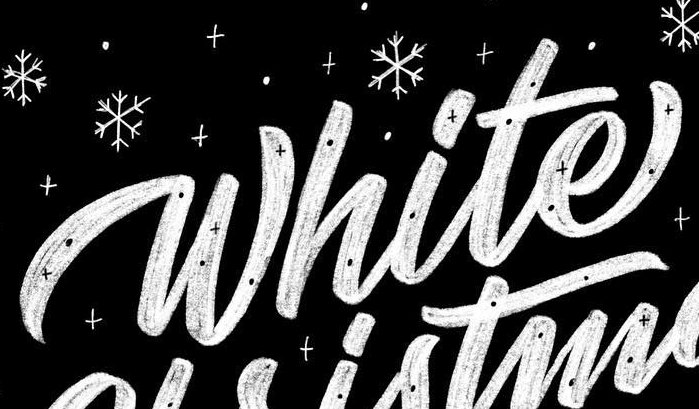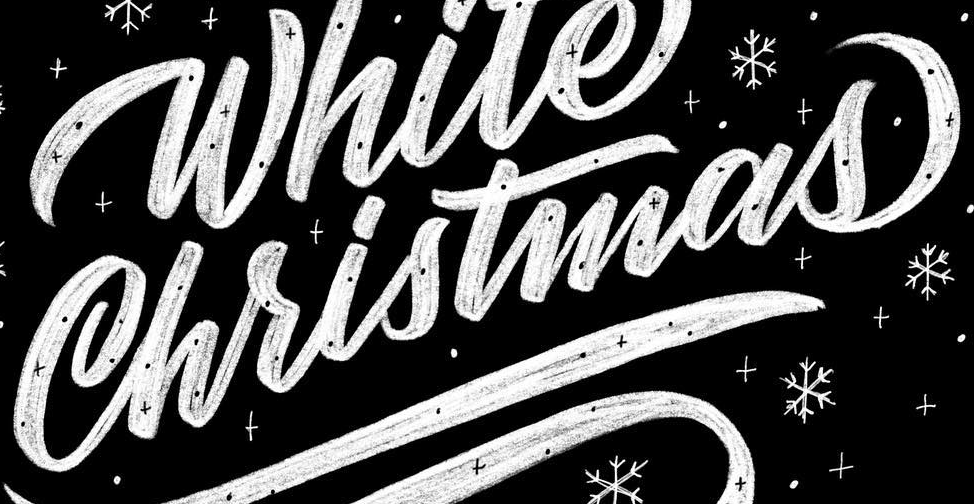What text is displayed in these images sequentially, separated by a semicolon? White; Christmas 